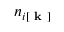<formula> <loc_0><loc_0><loc_500><loc_500>n _ { i [ k ] }</formula> 